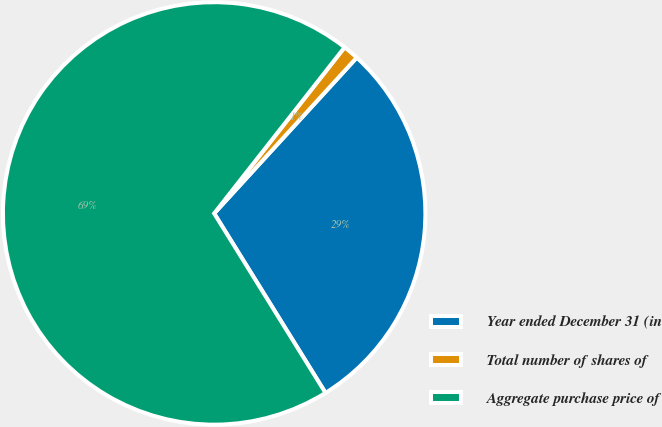Convert chart to OTSL. <chart><loc_0><loc_0><loc_500><loc_500><pie_chart><fcel>Year ended December 31 (in<fcel>Total number of shares of<fcel>Aggregate purchase price of<nl><fcel>29.37%<fcel>1.2%<fcel>69.43%<nl></chart> 